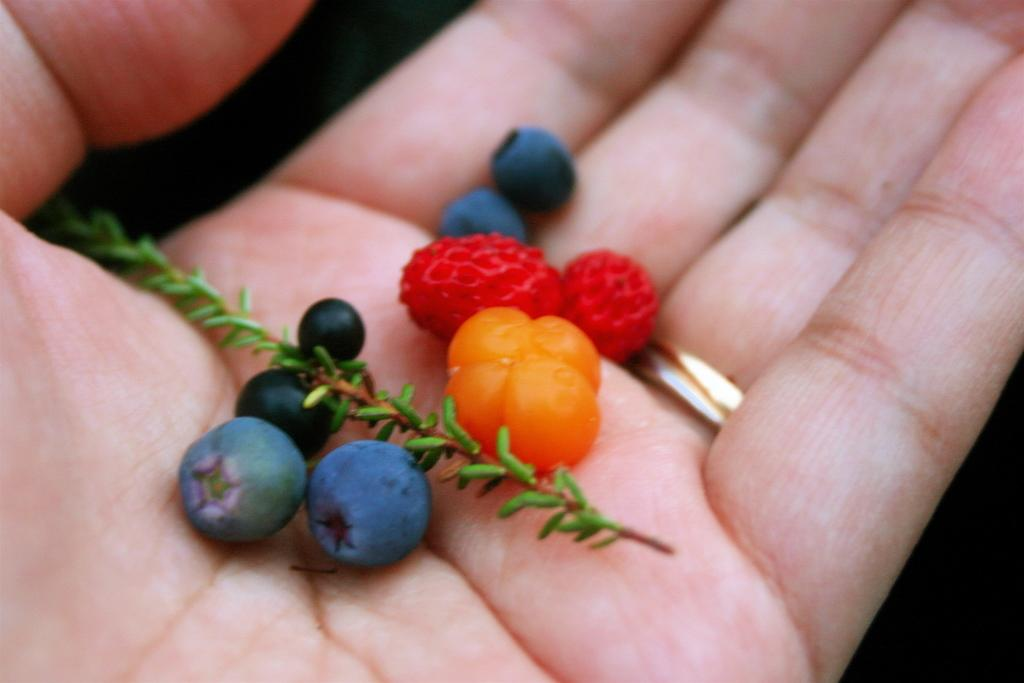What is the main subject of the image? The main subject of the image is a person's hand palm. What else can be seen in the image besides the hand? There are small fruits in the image. Can you describe the appearance of the small fruits? The small fruits are black, red, and pink in color. What type of machine is being used to prepare breakfast in the image? There is no machine or reference to breakfast in the image; it only features a person's hand palm and small fruits. 